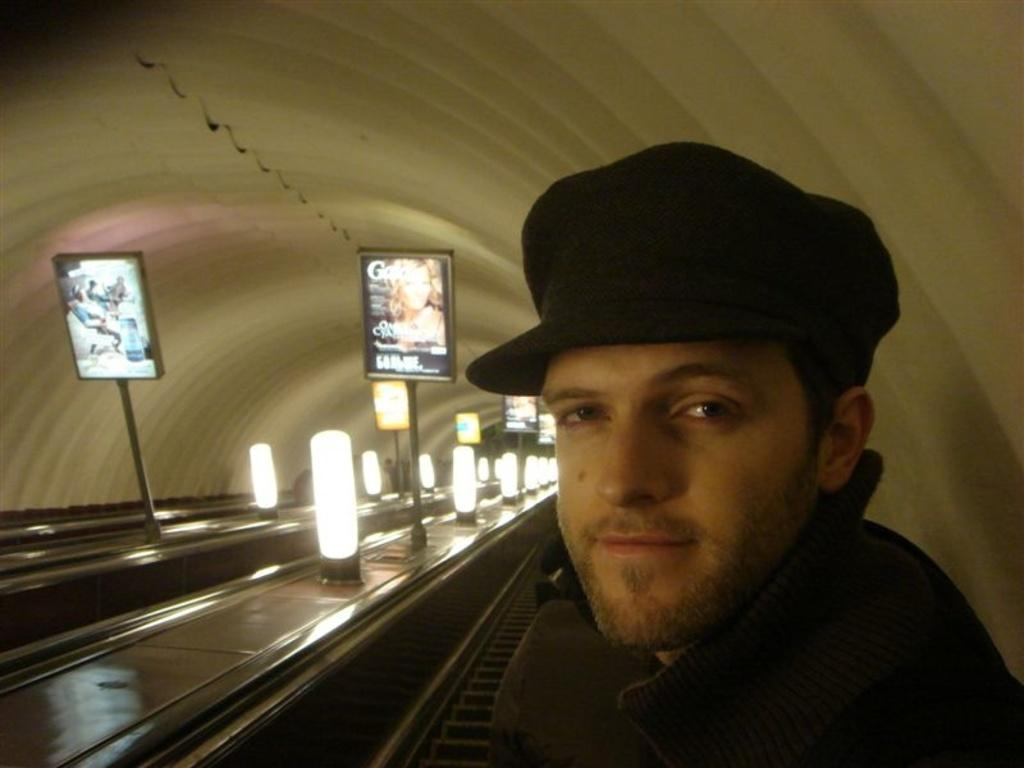Who is present in the image? There is a man in the image. What is the man doing in the image? The man is smiling in the image. What is the man wearing on his head? The man is wearing a cap in the image. What can be seen in the background of the image? There are boards with stands and lights in the background of the image. What type of faucet can be seen in the image? There is no faucet present in the image. How does the man maintain harmony with his parent in the image? There is no reference to a parent or harmony in the image, so it is not possible to answer that question. 